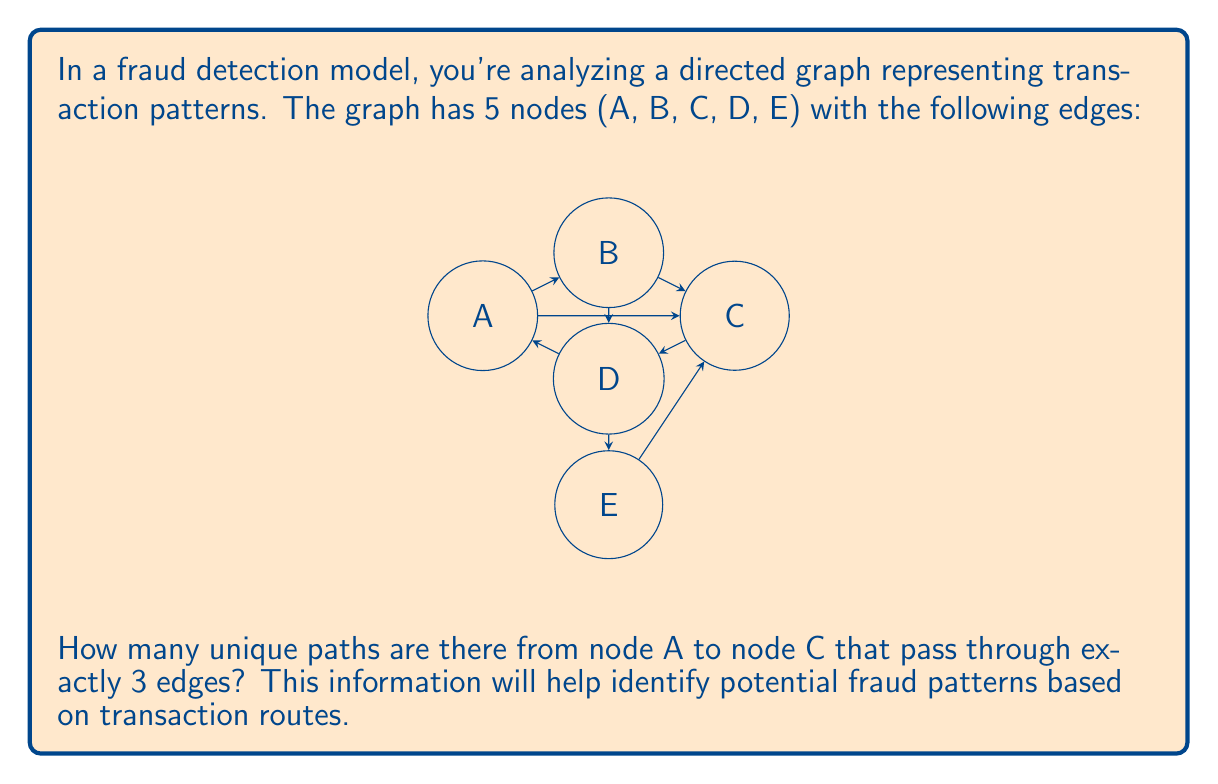Could you help me with this problem? To solve this problem, we'll use a systematic approach:

1) First, let's identify all possible 3-edge paths from A to C:
   
   a) A → B → C
   b) A → B → D → C
   c) A → C → D → C
   d) A → D → E → C

2) Now, let's count these paths:
   
   - Path (a) is valid and counts as 1
   - Path (b) is valid and counts as 1
   - Path (c) is valid and counts as 1
   - Path (d) is valid and counts as 1

3) Therefore, we have identified 4 unique paths from A to C that pass through exactly 3 edges.

This analysis helps in fraud detection by revealing the number of distinct transaction routes of a specific length between two points in the network. A higher number of paths might indicate more complex or potentially suspicious transaction patterns.
Answer: 4 